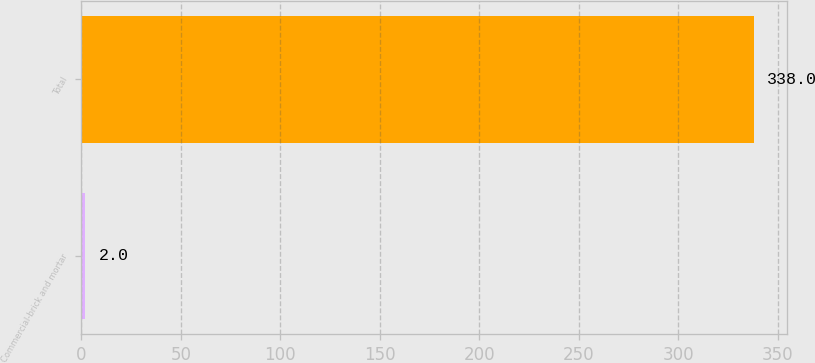Convert chart. <chart><loc_0><loc_0><loc_500><loc_500><bar_chart><fcel>Commercial-brick and mortar<fcel>Total<nl><fcel>2<fcel>338<nl></chart> 